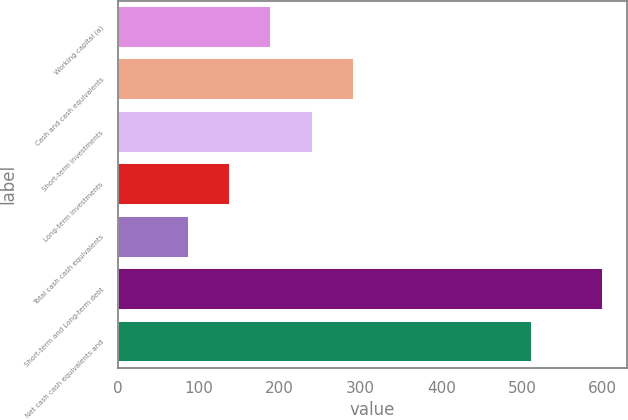Convert chart to OTSL. <chart><loc_0><loc_0><loc_500><loc_500><bar_chart><fcel>Working capital (a)<fcel>Cash and cash equivalents<fcel>Short-term investments<fcel>Long-term investments<fcel>Total cash cash equivalents<fcel>Short-term and Long-term debt<fcel>Net cash cash equivalents and<nl><fcel>189.78<fcel>292.26<fcel>241.02<fcel>138.54<fcel>87.3<fcel>599.7<fcel>512.4<nl></chart> 